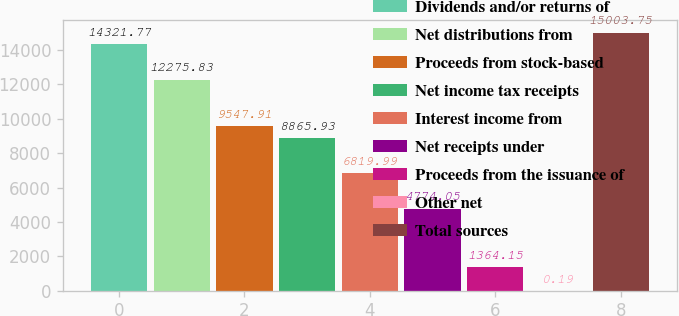<chart> <loc_0><loc_0><loc_500><loc_500><bar_chart><fcel>Dividends and/or returns of<fcel>Net distributions from<fcel>Proceeds from stock-based<fcel>Net income tax receipts<fcel>Interest income from<fcel>Net receipts under<fcel>Proceeds from the issuance of<fcel>Other net<fcel>Total sources<nl><fcel>14321.8<fcel>12275.8<fcel>9547.91<fcel>8865.93<fcel>6819.99<fcel>4774.05<fcel>1364.15<fcel>0.19<fcel>15003.8<nl></chart> 